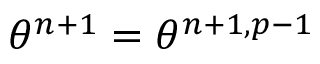<formula> <loc_0><loc_0><loc_500><loc_500>\theta ^ { n + 1 } = \theta ^ { n + 1 , p - 1 }</formula> 